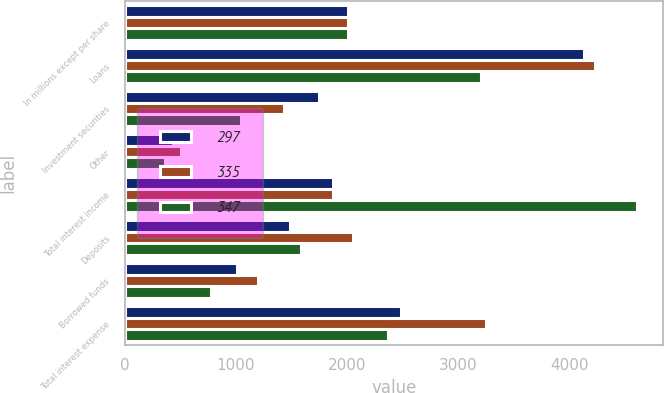Convert chart. <chart><loc_0><loc_0><loc_500><loc_500><stacked_bar_chart><ecel><fcel>In millions except per share<fcel>Loans<fcel>Investment securities<fcel>Other<fcel>Total interest income<fcel>Deposits<fcel>Borrowed funds<fcel>Total interest expense<nl><fcel>297<fcel>2008<fcel>4138<fcel>1746<fcel>429<fcel>1876<fcel>1485<fcel>1005<fcel>2490<nl><fcel>335<fcel>2007<fcel>4232<fcel>1429<fcel>505<fcel>1876<fcel>2053<fcel>1198<fcel>3251<nl><fcel>347<fcel>2006<fcel>3203<fcel>1049<fcel>360<fcel>4612<fcel>1590<fcel>777<fcel>2367<nl></chart> 